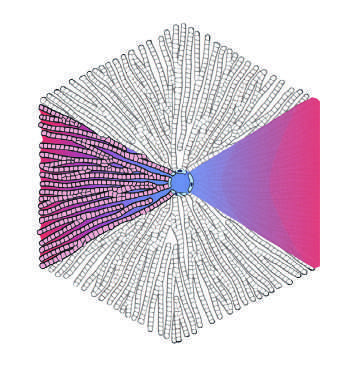what is the farthest?
Answer the question using a single word or phrase. Zone 3 